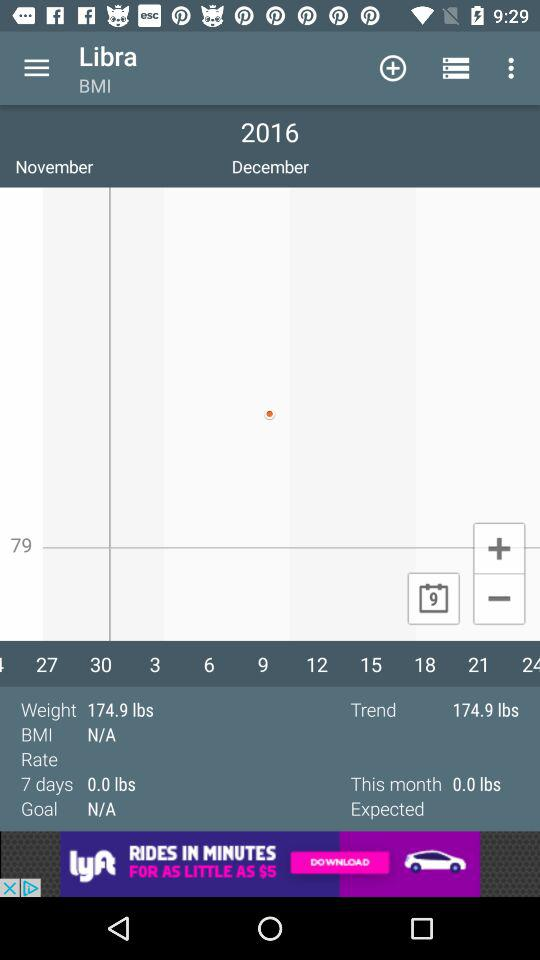What is the trend? The trend is 174.9 lbs. 